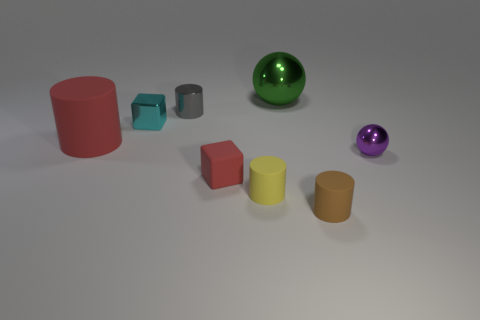There is a green shiny object that is the same shape as the purple metallic object; what size is it?
Provide a short and direct response. Large. What is the size of the shiny thing that is both on the right side of the gray cylinder and left of the purple ball?
Your answer should be very brief. Large. Does the tiny matte block have the same color as the matte thing that is on the left side of the gray thing?
Your answer should be very brief. Yes. How many yellow objects are either big cylinders or small blocks?
Your answer should be compact. 0. What is the shape of the green metal thing?
Your answer should be compact. Sphere. What number of other things are there of the same shape as the gray thing?
Your response must be concise. 3. What is the color of the metallic ball that is to the right of the green shiny sphere?
Give a very brief answer. Purple. Is the green ball made of the same material as the purple object?
Offer a very short reply. Yes. How many objects are green things or big objects that are on the right side of the red cylinder?
Offer a very short reply. 1. What is the size of the object that is the same color as the tiny rubber block?
Keep it short and to the point. Large. 